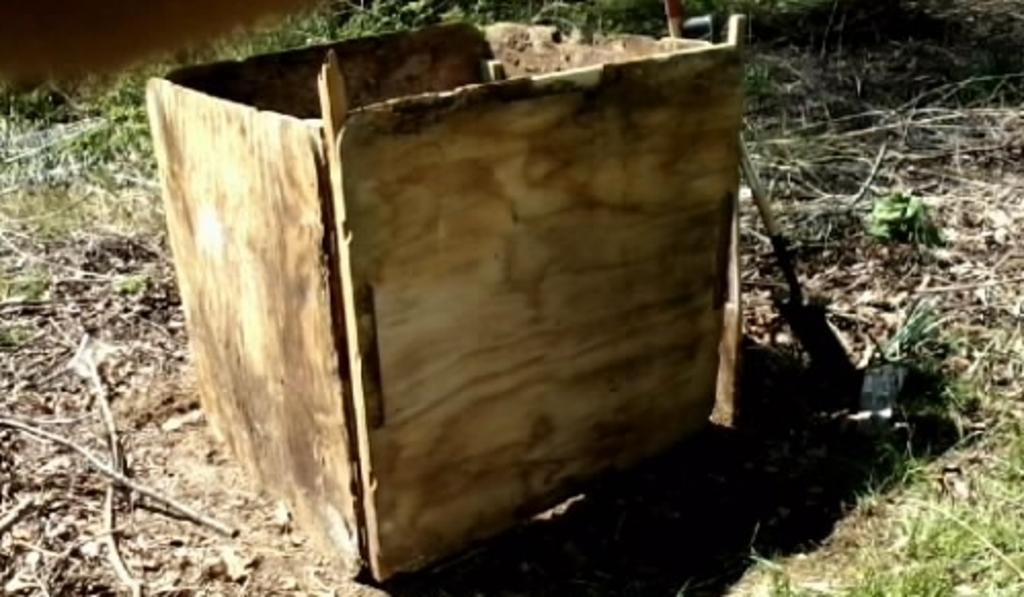What is the main object in the middle of the image? There is a wooden box in the middle of the image. What type of surface is visible at the bottom of the image? There is grass and sticks at the bottom of the image. What can be seen in the background of the image? There are plants in the background of the image. What type of spark can be seen coming from the horse in the image? There is no horse present in the image, so there cannot be any spark coming from it. 